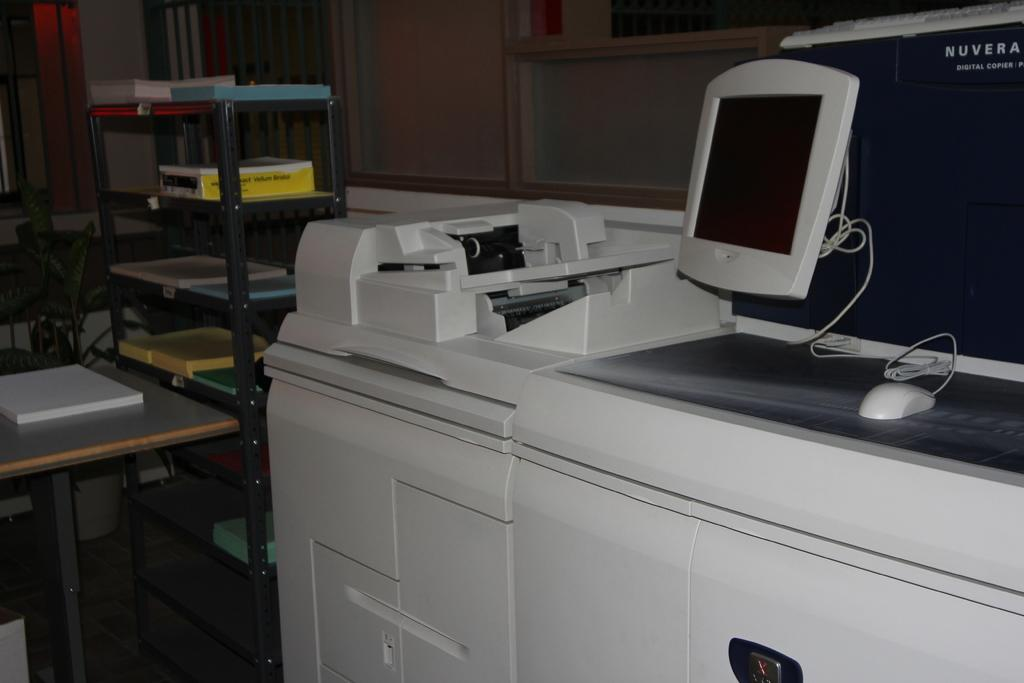<image>
Relay a brief, clear account of the picture shown. Computer monitor that says Nuvera on top of a white desk. 